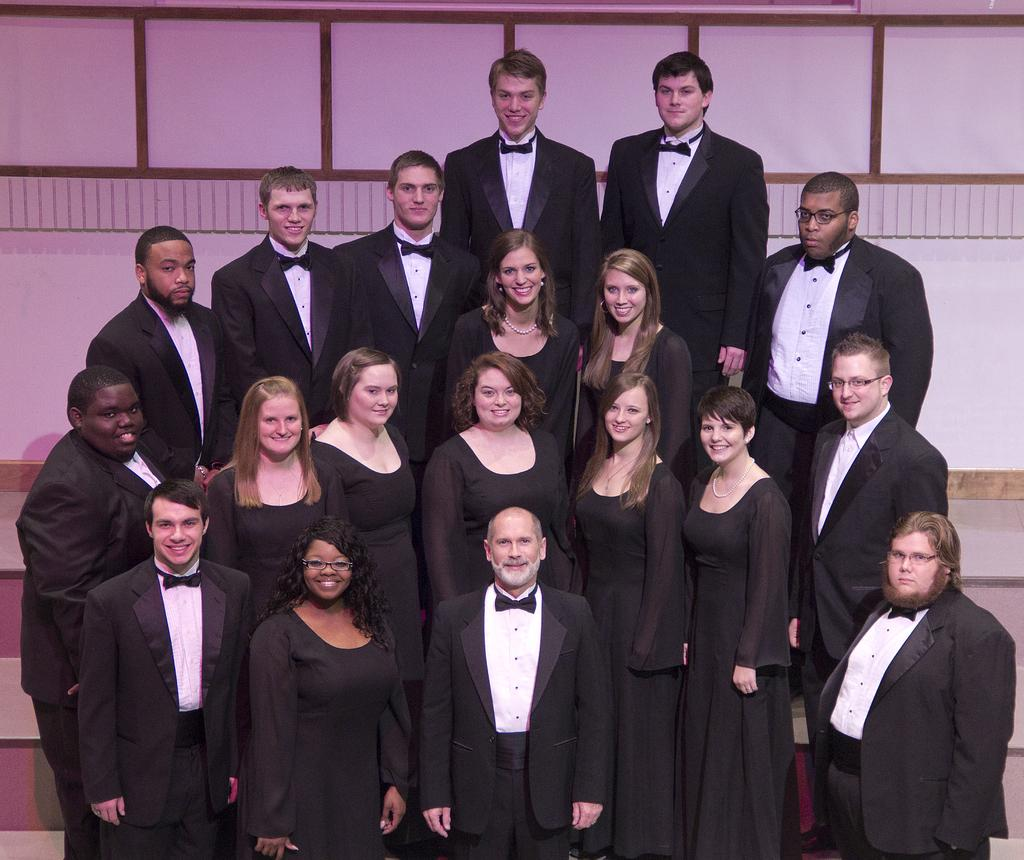What is the main subject of the image? The main subject of the image is a group of people. What are the people wearing in the image? The people are wearing black and white costumes. What are the people doing in the image? The people are standing and smiling. What can be seen in the background of the image? There is a wall in the background of the image. Can you tell me how many tigers are visible in the image? There are no tigers present in the image; it features a group of people wearing costumes. What type of bag is being used by the people in the image? There is no bag visible in the image; the people are wearing costumes and standing. 